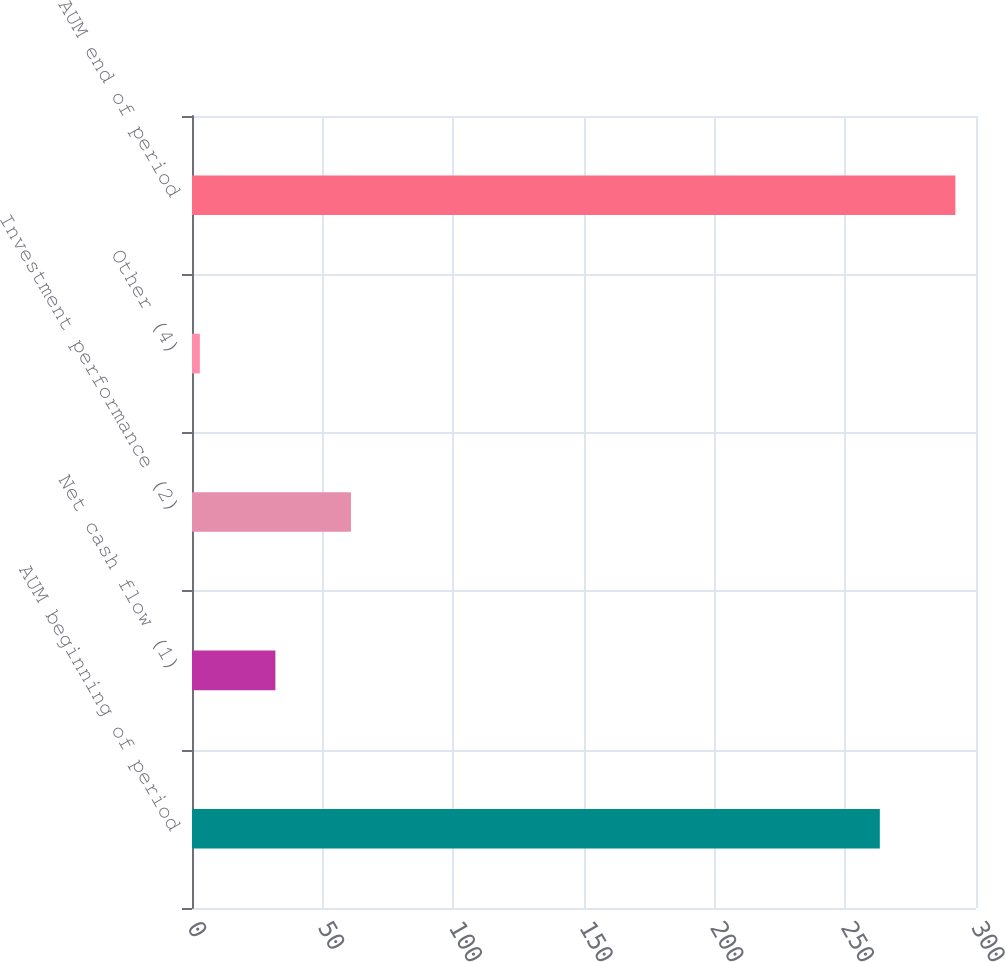Convert chart to OTSL. <chart><loc_0><loc_0><loc_500><loc_500><bar_chart><fcel>AUM beginning of period<fcel>Net cash flow (1)<fcel>Investment performance (2)<fcel>Other (4)<fcel>AUM end of period<nl><fcel>263.2<fcel>31.91<fcel>60.82<fcel>3<fcel>292.11<nl></chart> 